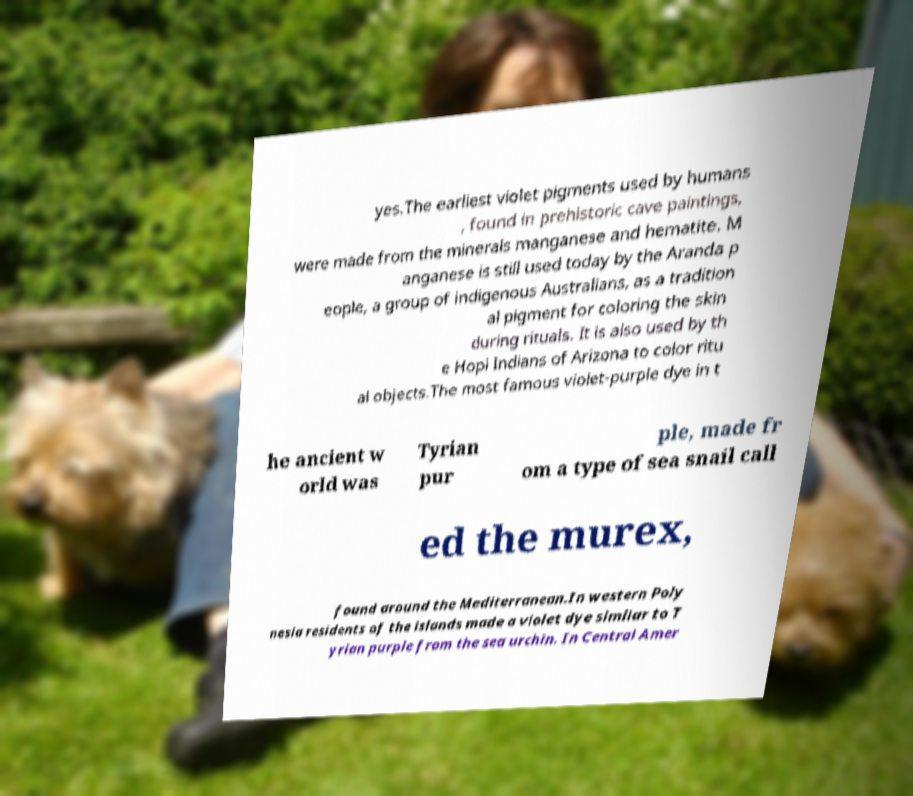Please read and relay the text visible in this image. What does it say? yes.The earliest violet pigments used by humans , found in prehistoric cave paintings, were made from the minerals manganese and hematite. M anganese is still used today by the Aranda p eople, a group of indigenous Australians, as a tradition al pigment for coloring the skin during rituals. It is also used by th e Hopi Indians of Arizona to color ritu al objects.The most famous violet-purple dye in t he ancient w orld was Tyrian pur ple, made fr om a type of sea snail call ed the murex, found around the Mediterranean.In western Poly nesia residents of the islands made a violet dye similar to T yrian purple from the sea urchin. In Central Amer 